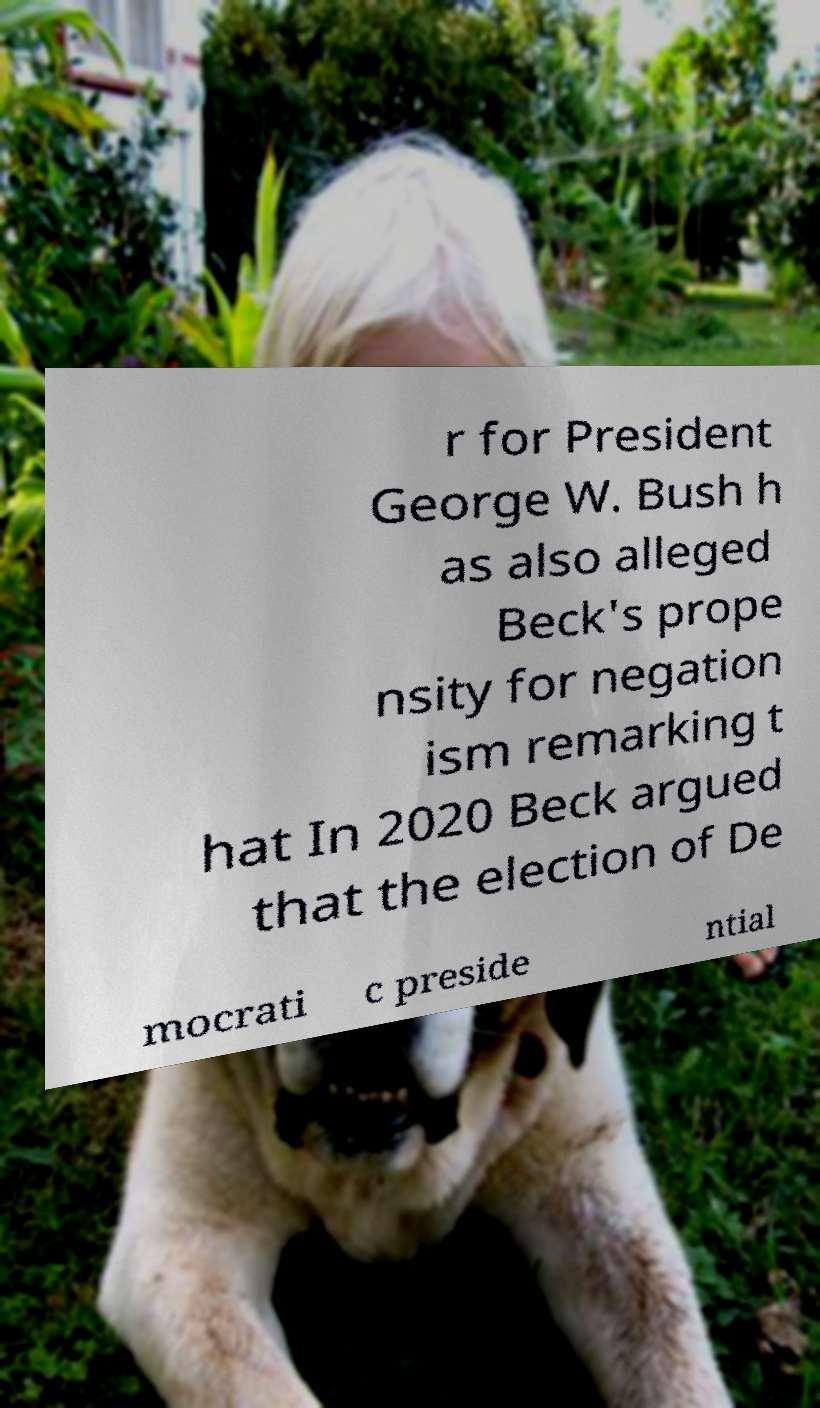I need the written content from this picture converted into text. Can you do that? r for President George W. Bush h as also alleged Beck's prope nsity for negation ism remarking t hat In 2020 Beck argued that the election of De mocrati c preside ntial 